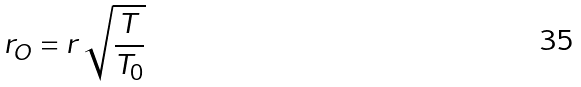<formula> <loc_0><loc_0><loc_500><loc_500>r _ { O } = r \, \sqrt { \frac { T } { T _ { 0 } } }</formula> 